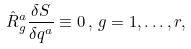Convert formula to latex. <formula><loc_0><loc_0><loc_500><loc_500>\hat { R } _ { g } ^ { a } \frac { \delta S } { \delta q ^ { a } } \equiv 0 \, , \, g = 1 , \dots , r ,</formula> 